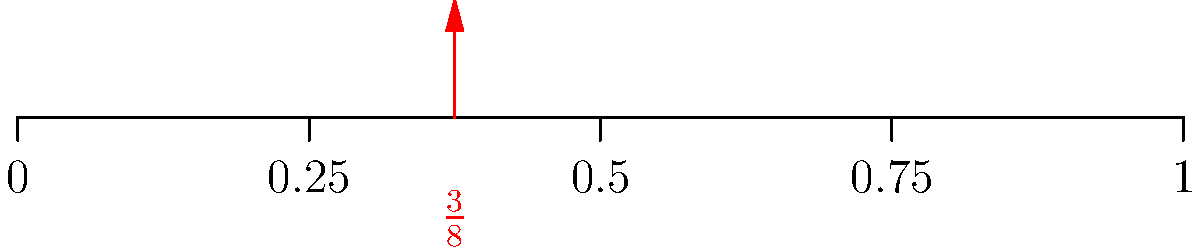On the number line above, the fraction $\frac{3}{8}$ is marked. What is this fraction expressed as a decimal? Let's convert $\frac{3}{8}$ to a decimal step-by-step:

1) First, we can see that $\frac{3}{8}$ is between $\frac{1}{4}$ (0.25) and $\frac{1}{2}$ (0.5) on the number line.

2) To convert a fraction to a decimal, we divide the numerator by the denominator:

   $\frac{3}{8} = 3 \div 8$

3) Let's perform this division:
   
   $3 \div 8 = 0.375$

4) We can verify this on the number line:
   - $0.375$ is indeed between $0.25$ and $0.5$
   - It's closer to $0.25$ (1/4) than to $0.5$ (1/2), which matches the position of $\frac{3}{8}$ on the number line

Therefore, $\frac{3}{8}$ expressed as a decimal is $0.375$.
Answer: $0.375$ 